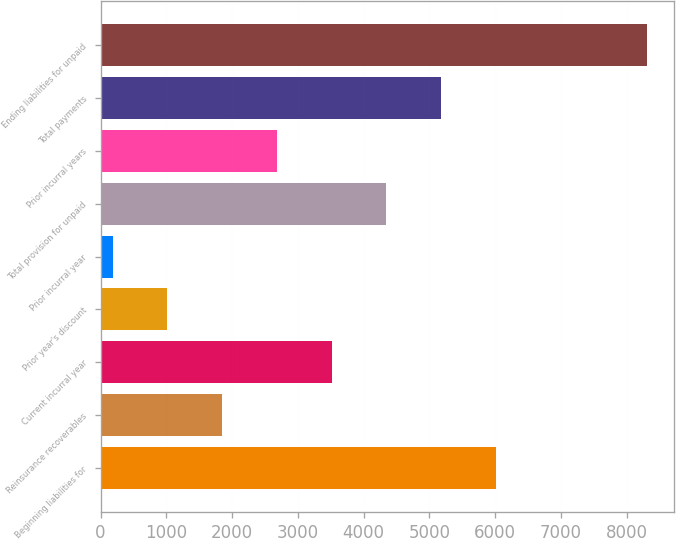<chart> <loc_0><loc_0><loc_500><loc_500><bar_chart><fcel>Beginning liabilities for<fcel>Reinsurance recoverables<fcel>Current incurral year<fcel>Prior year's discount<fcel>Prior incurral year<fcel>Total provision for unpaid<fcel>Prior incurral years<fcel>Total payments<fcel>Ending liabilities for unpaid<nl><fcel>6013.9<fcel>1850.4<fcel>3515.8<fcel>1017.7<fcel>185<fcel>4348.5<fcel>2683.1<fcel>5181.2<fcel>8303<nl></chart> 